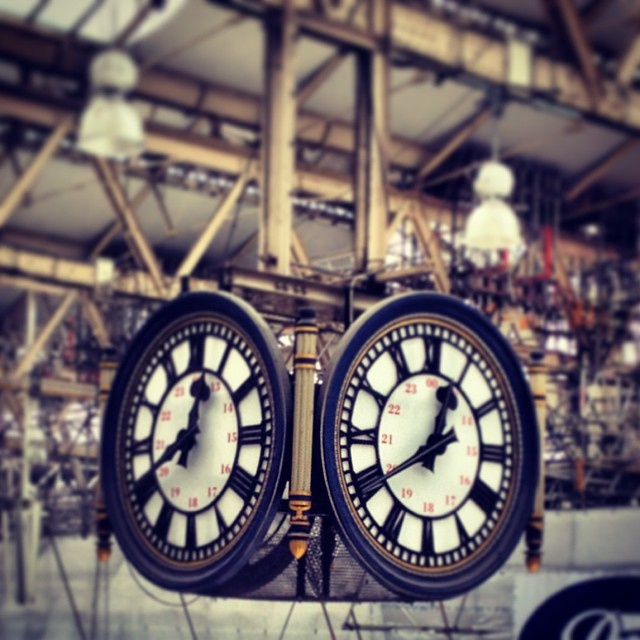Describe the objects in this image and their specific colors. I can see clock in lightgray, beige, navy, and gray tones and clock in lightgray, navy, gray, and darkgray tones in this image. 